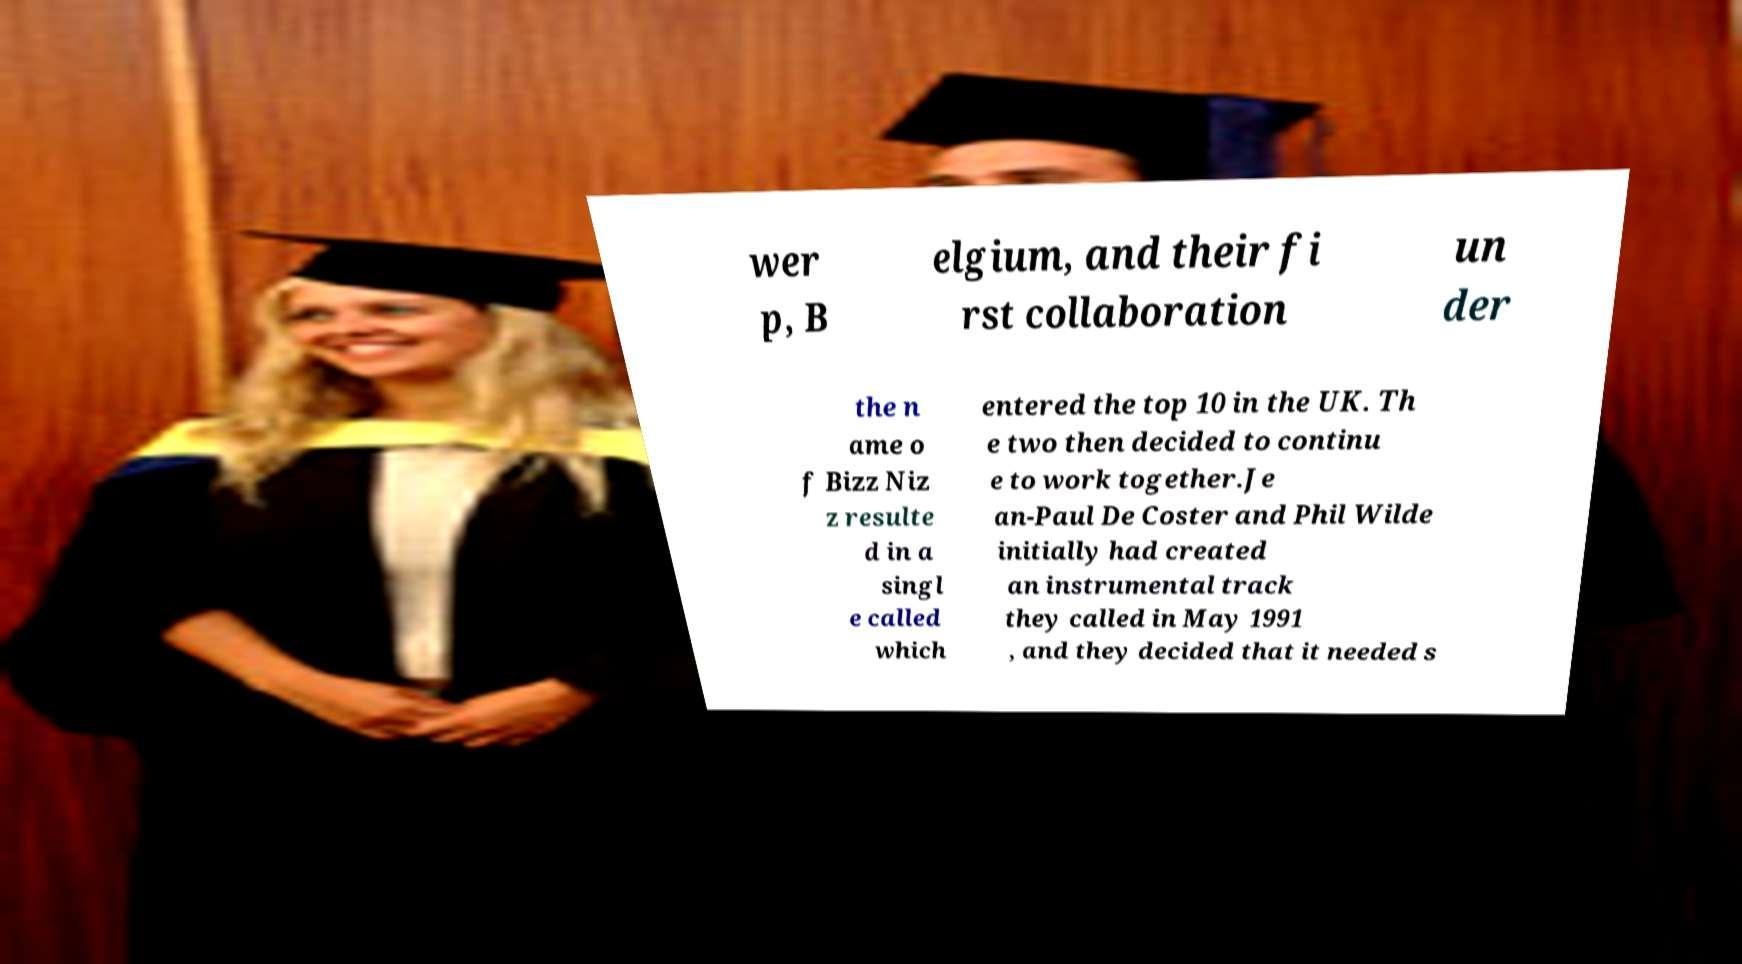Can you accurately transcribe the text from the provided image for me? wer p, B elgium, and their fi rst collaboration un der the n ame o f Bizz Niz z resulte d in a singl e called which entered the top 10 in the UK. Th e two then decided to continu e to work together.Je an-Paul De Coster and Phil Wilde initially had created an instrumental track they called in May 1991 , and they decided that it needed s 